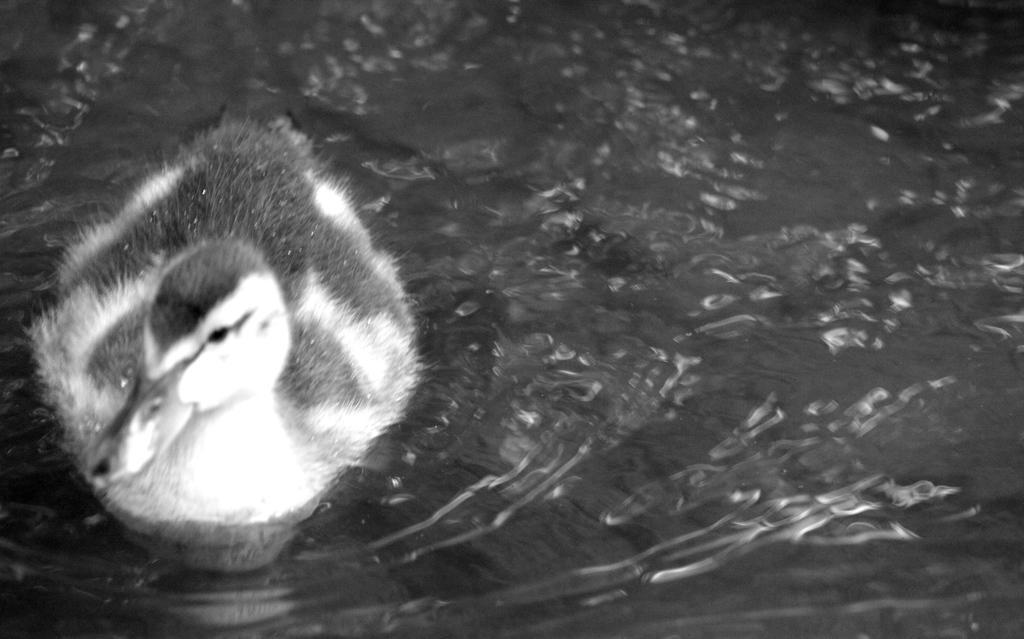In one or two sentences, can you explain what this image depicts? In the image there is a duck swimming in the water, this is a black white picture. 